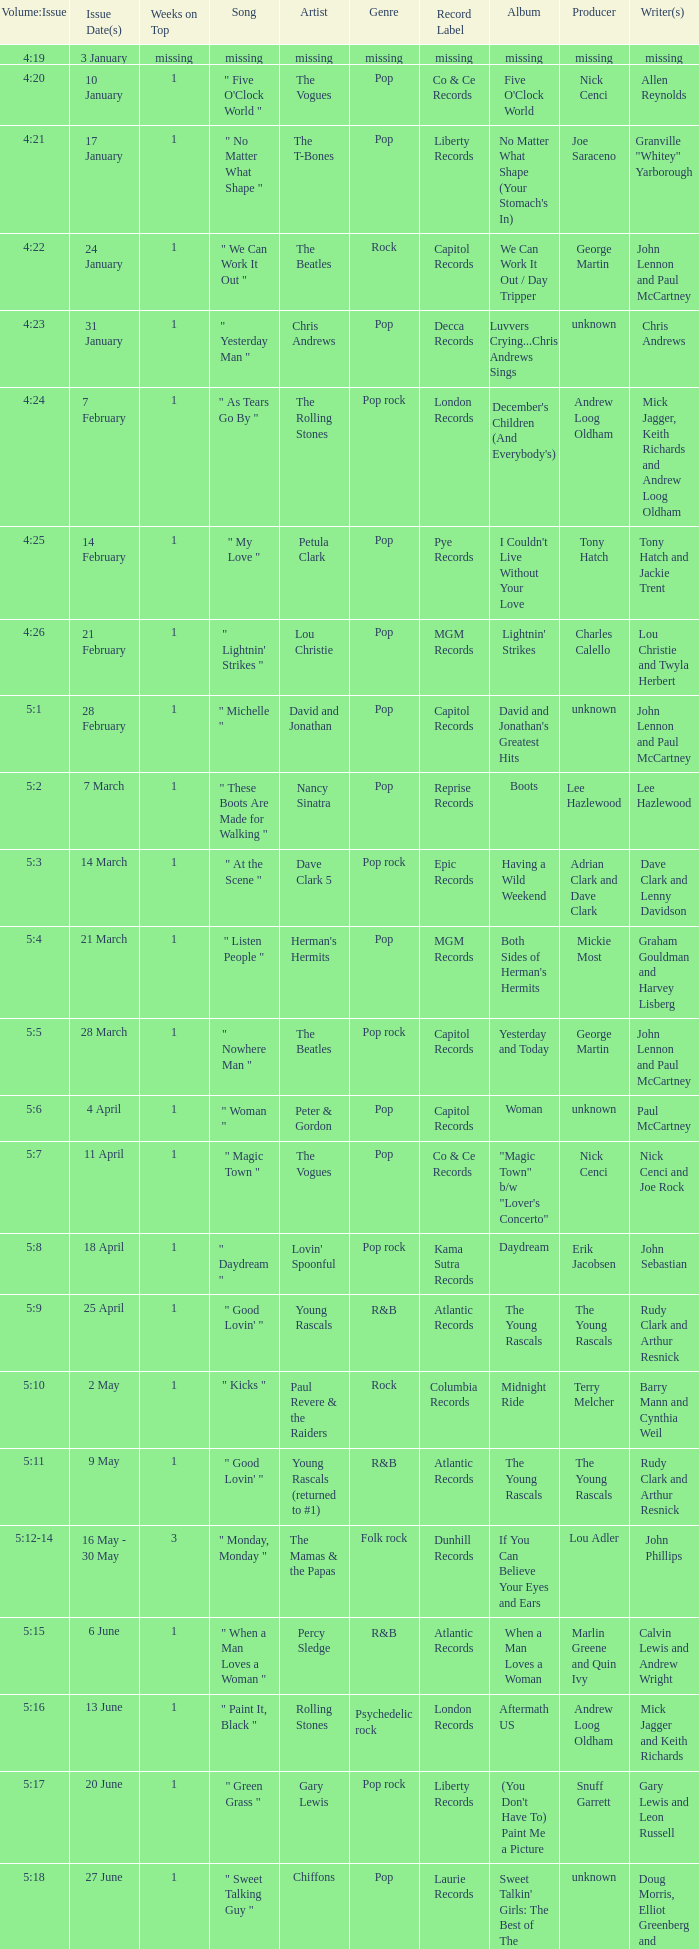With an issue date(s) of 12 September, what is in the column for Weeks on Top? 1.0. Could you parse the entire table? {'header': ['Volume:Issue', 'Issue Date(s)', 'Weeks on Top', 'Song', 'Artist', 'Genre', 'Record Label', 'Album', 'Producer', 'Writer(s) '], 'rows': [['4:19', '3 January', 'missing', 'missing', 'missing', 'missing', 'missing', 'missing', 'missing', 'missing'], ['4:20', '10 January', '1', '" Five O\'Clock World "', 'The Vogues', 'Pop', 'Co & Ce Records', "Five O'Clock World", 'Nick Cenci', 'Allen Reynolds'], ['4:21', '17 January', '1', '" No Matter What Shape "', 'The T-Bones', 'Pop', 'Liberty Records', "No Matter What Shape (Your Stomach's In)", 'Joe Saraceno', 'Granville "Whitey" Yarborough'], ['4:22', '24 January', '1', '" We Can Work It Out "', 'The Beatles', 'Rock', 'Capitol Records', 'We Can Work It Out / Day Tripper', 'George Martin', 'John Lennon and Paul McCartney'], ['4:23', '31 January', '1', '" Yesterday Man "', 'Chris Andrews', 'Pop', 'Decca Records', 'Luvvers Crying...Chris Andrews Sings', 'unknown', 'Chris Andrews'], ['4:24', '7 February', '1', '" As Tears Go By "', 'The Rolling Stones', 'Pop rock', 'London Records', "December's Children (And Everybody's)", 'Andrew Loog Oldham', 'Mick Jagger, Keith Richards and Andrew Loog Oldham'], ['4:25', '14 February', '1', '" My Love "', 'Petula Clark', 'Pop', 'Pye Records', "I Couldn't Live Without Your Love", 'Tony Hatch', 'Tony Hatch and Jackie Trent'], ['4:26', '21 February', '1', '" Lightnin\' Strikes "', 'Lou Christie', 'Pop', 'MGM Records', "Lightnin' Strikes", 'Charles Calello', 'Lou Christie and Twyla Herbert'], ['5:1', '28 February', '1', '" Michelle "', 'David and Jonathan', 'Pop', 'Capitol Records', "David and Jonathan's Greatest Hits", 'unknown', 'John Lennon and Paul McCartney'], ['5:2', '7 March', '1', '" These Boots Are Made for Walking "', 'Nancy Sinatra', 'Pop', 'Reprise Records', 'Boots', 'Lee Hazlewood', 'Lee Hazlewood'], ['5:3', '14 March', '1', '" At the Scene "', 'Dave Clark 5', 'Pop rock', 'Epic Records', 'Having a Wild Weekend', 'Adrian Clark and Dave Clark', 'Dave Clark and Lenny Davidson'], ['5:4', '21 March', '1', '" Listen People "', "Herman's Hermits", 'Pop', 'MGM Records', "Both Sides of Herman's Hermits", 'Mickie Most', 'Graham Gouldman and Harvey Lisberg'], ['5:5', '28 March', '1', '" Nowhere Man "', 'The Beatles', 'Pop rock', 'Capitol Records', 'Yesterday and Today', 'George Martin', 'John Lennon and Paul McCartney'], ['5:6', '4 April', '1', '" Woman "', 'Peter & Gordon', 'Pop', 'Capitol Records', 'Woman', 'unknown', 'Paul McCartney'], ['5:7', '11 April', '1', '" Magic Town "', 'The Vogues', 'Pop', 'Co & Ce Records', '"Magic Town" b/w "Lover\'s Concerto"', 'Nick Cenci', 'Nick Cenci and Joe Rock'], ['5:8', '18 April', '1', '" Daydream "', "Lovin' Spoonful", 'Pop rock', 'Kama Sutra Records', 'Daydream', 'Erik Jacobsen', 'John Sebastian'], ['5:9', '25 April', '1', '" Good Lovin\' "', 'Young Rascals', 'R&B', 'Atlantic Records', 'The Young Rascals', 'The Young Rascals', 'Rudy Clark and Arthur Resnick'], ['5:10', '2 May', '1', '" Kicks "', 'Paul Revere & the Raiders', 'Rock', 'Columbia Records', 'Midnight Ride', 'Terry Melcher', 'Barry Mann and Cynthia Weil'], ['5:11', '9 May', '1', '" Good Lovin\' "', 'Young Rascals (returned to #1)', 'R&B', 'Atlantic Records', 'The Young Rascals', 'The Young Rascals', 'Rudy Clark and Arthur Resnick'], ['5:12-14', '16 May - 30 May', '3', '" Monday, Monday "', 'The Mamas & the Papas', 'Folk rock', 'Dunhill Records', 'If You Can Believe Your Eyes and Ears', 'Lou Adler', 'John Phillips'], ['5:15', '6 June', '1', '" When a Man Loves a Woman "', 'Percy Sledge', 'R&B', 'Atlantic Records', 'When a Man Loves a Woman', 'Marlin Greene and Quin Ivy', 'Calvin Lewis and Andrew Wright'], ['5:16', '13 June', '1', '" Paint It, Black "', 'Rolling Stones', 'Psychedelic rock', 'London Records', 'Aftermath US', 'Andrew Loog Oldham', 'Mick Jagger and Keith Richards'], ['5:17', '20 June', '1', '" Green Grass "', 'Gary Lewis', 'Pop rock', 'Liberty Records', "(You Don't Have To) Paint Me a Picture", 'Snuff Garrett', 'Gary Lewis and Leon Russell'], ['5:18', '27 June', '1', '" Sweet Talking Guy "', 'Chiffons', 'Pop', 'Laurie Records', "Sweet Talkin' Girls: The Best of The Chiffons", 'unknown', 'Doug Morris, Elliot Greenberg and Barbara Baer'], ['5:19', '4 July', '1', '" Paperback Writer "', 'The Beatles', 'Rock', 'Capitol Records', '"Paperback Writer" b/w "Rain"', 'George Martin', 'John Lennon and Paul McCartney'], ['5:20', '11 July', '1', '" Red Rubber Ball "', 'The Cyrkle', 'Pop rock', 'Columbia Records', 'Red Rubber Ball', 'John Simon', 'Paul Simon and Bruce Woodley'], ['5:21', '18 July', '1', '" The Pied Piper "', 'Crispian St. Peters', 'Pop', 'Decca Records', 'Follow Me...', 'unknown', 'Steve Duboff and Artie Kornfeld'], ['5:22', '25 July', '1', '" Hanky Panky "', 'Tommy James and the Shondells', 'Pop rock', 'Roulette Records', 'Hanky Panky', 'unknown', 'Jeff Barry and Ellie Greenwich'], ['5:23', '1 August', '1', '" Sweet Pea "', 'Tommy Roe', 'Pop', 'ABC Records', 'Sweet Pea', 'unknown', 'Tommy Roe'], ['5:24', '8 August', '1', '" I Saw Her Again "', 'The Mamas & the Papas', 'Folk rock', 'Dunhill Records', 'The Mamas & The Papas Deliver', 'Lou Adler', 'John Phillips and Denny Doherty'], ['5:25-26', '15 August - 22 August', '2', '" Summer in the City "', "Lovin' Spoonful", 'Pop rock', 'Kama Sutra Records', "Hums of The Lovin' Spoonful", 'Erik Jacobsen', 'John Sebastian, Steve Boone and Mark Sebastian'], ['6:1', '29 August', '1', '" See You in September "', 'The Happenings', 'Pop', 'B.T. Puppy Records', 'Potpourri Of Hits', 'Bob Crewe', 'Sid Wayne and Sherman Edwards'], ['6:2', '5 September', '1', '" Bus Stop "', 'The Hollies', 'Pop rock', 'Imperial Records', 'Bus Stop', 'Ron Richards', 'Graham Gouldman'], ['6:3', '12 September', '1', '" Get Away "', 'Georgie Fame', 'R&B', 'Imperial Records', 'Sweet Thing', 'unknown', 'Bert Kaempfert and Herbert Rehbein'], ['6:4', '19 September', '1', '" Yellow Submarine "/" Eleanor Rigby "', 'The Beatles', 'Psychedelic rock', 'Parlophone Records', '"Yellow Submarine" b/w "Eleanor Rigby"', 'George Martin', 'John Lennon and Paul McCartney'], ['6:5', '26 September', '1', '" Sunny Afternoon "', 'The Kinks', 'Pop rock', 'Pye Records', 'Face to Face', 'Shel Talmy', 'Ray Davies'], ['6:6', '3 October', '1', '" Cherish "', 'The Association', 'Pop', 'Valiant Records', 'And Then...Along Comes The Association', 'Curt Boettcher', 'Terry Kirkman'], ['6:7', '10 October', '1', '" Black Is Black "', 'Los Bravos', 'Pop rock', 'Decca Records', 'Black Is Black', 'unknown', 'Michel Grainger, Steve Wadey and Tony Hayes'], ['6:8-9', '17 October - 24 October', '2', '" See See Rider "', 'Eric Burdon and The Animals', 'R&B', 'MGM Records', 'Eric Is Here', 'Tom Wilson', 'Ma Rainey'], ['6:10', '31 October', '1', '" 96 Tears "', 'Question Mark & the Mysterians', 'Garage rock', 'Cameo Records', '96 Tears', 'Rudy Martinez', 'Rudy Martinez'], ['6:11', '7 November', '1', '" Last Train to Clarksville "', 'The Monkees', 'Pop rock', 'Colgems Records', 'The Monkees', 'Tommy Boyce and Bobby Hart', 'Tommy Boyce and Bobby Hart'], ['6:12', '14 November', '1', '" Dandy "', "Herman's Hermits", 'Pop', 'MGM Records', 'Blaze', 'Mickie Most', 'Ray Davies'], ['6:13', '21 November', '1', '" Poor Side of Town "', 'Johnny Rivers', 'Pop', 'Imperial Records', '...And I Know You Wanna Dance', 'Lou Adler', 'Johnny Rivers and Lou Adler'], ['6:14-15', '28 November - 5 December', '2', '" Winchester Cathedral "', 'New Vaudeville Band', 'Pop', 'Fontana Records', 'Winchester Cathedral', 'Geoff Stephens', 'Geoff Stephens'], ['6:16', '12 December', '1', '" Lady Godiva "', 'Peter & Gordon', 'Pop', 'Capitol Records', 'Lady Godiva', 'Peter Asher', 'Mike Leander and Charles Mills'], ['6:17', '19 December', '1', '" Stop! Stop! Stop! "', 'The Hollies', 'Pop rock', 'Imperial Records', 'For Certain Because...', 'Ron Richards', 'Allan Clarke, Tony Hicks and Graham Nash'], ['6:18-19', '26 December - 2 January', '2', '" I\'m a Believer "', 'The Monkees', 'Pop rock', 'Colgems Records', 'More of the Monkees', 'Jeff Barry', 'Neil Diamond']]} 